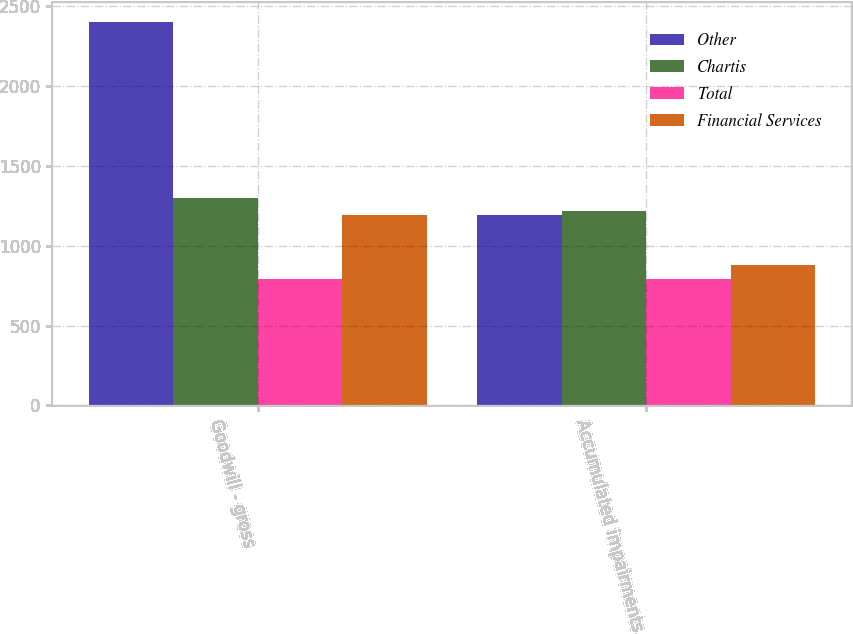Convert chart. <chart><loc_0><loc_0><loc_500><loc_500><stacked_bar_chart><ecel><fcel>Goodwill - gross<fcel>Accumulated impairments<nl><fcel>Other<fcel>2405<fcel>1196<nl><fcel>Chartis<fcel>1301<fcel>1220<nl><fcel>Total<fcel>791<fcel>791<nl><fcel>Financial Services<fcel>1196<fcel>878<nl></chart> 